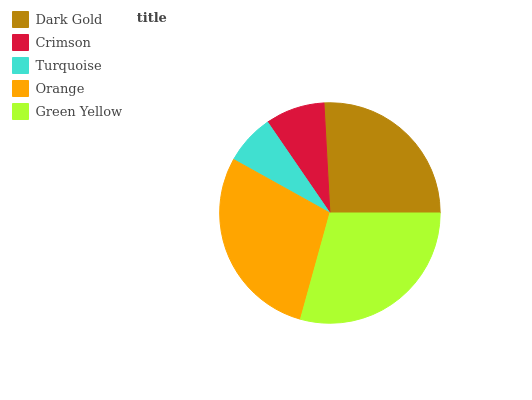Is Turquoise the minimum?
Answer yes or no. Yes. Is Green Yellow the maximum?
Answer yes or no. Yes. Is Crimson the minimum?
Answer yes or no. No. Is Crimson the maximum?
Answer yes or no. No. Is Dark Gold greater than Crimson?
Answer yes or no. Yes. Is Crimson less than Dark Gold?
Answer yes or no. Yes. Is Crimson greater than Dark Gold?
Answer yes or no. No. Is Dark Gold less than Crimson?
Answer yes or no. No. Is Dark Gold the high median?
Answer yes or no. Yes. Is Dark Gold the low median?
Answer yes or no. Yes. Is Turquoise the high median?
Answer yes or no. No. Is Orange the low median?
Answer yes or no. No. 